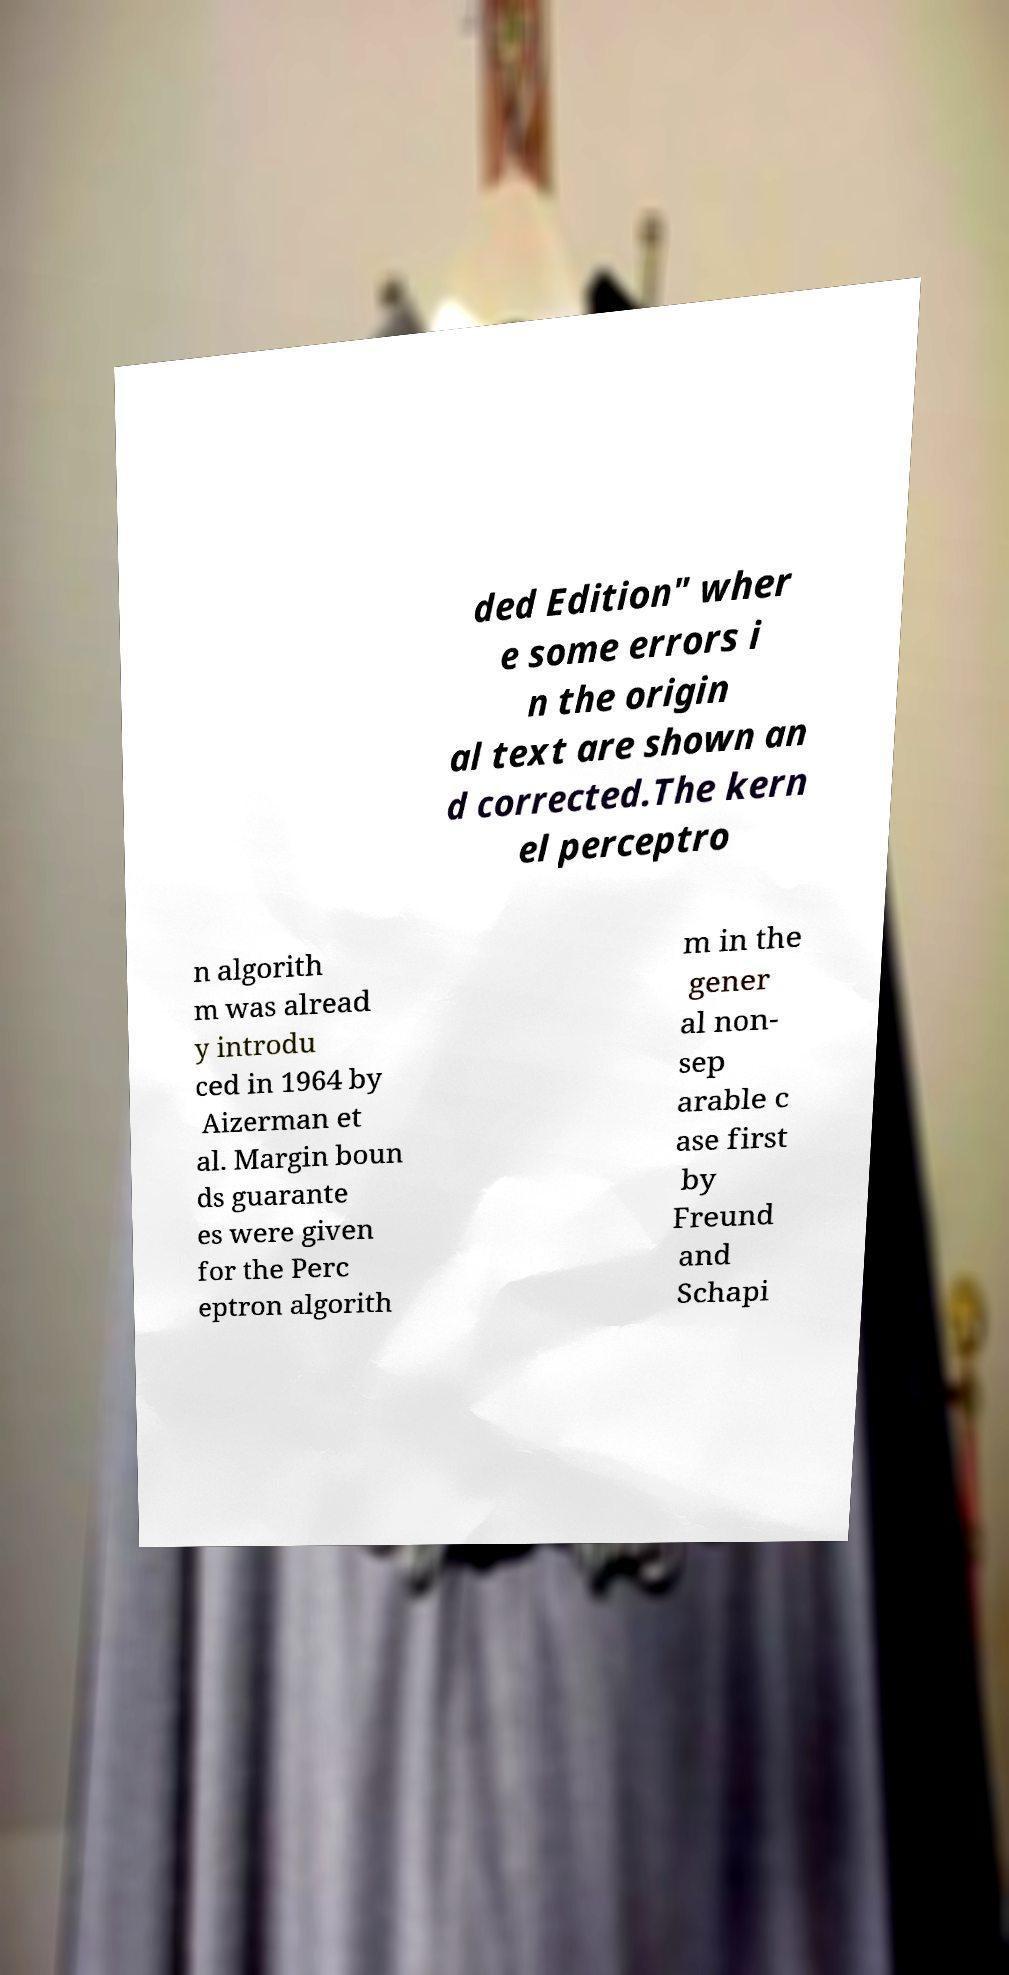What messages or text are displayed in this image? I need them in a readable, typed format. ded Edition" wher e some errors i n the origin al text are shown an d corrected.The kern el perceptro n algorith m was alread y introdu ced in 1964 by Aizerman et al. Margin boun ds guarante es were given for the Perc eptron algorith m in the gener al non- sep arable c ase first by Freund and Schapi 